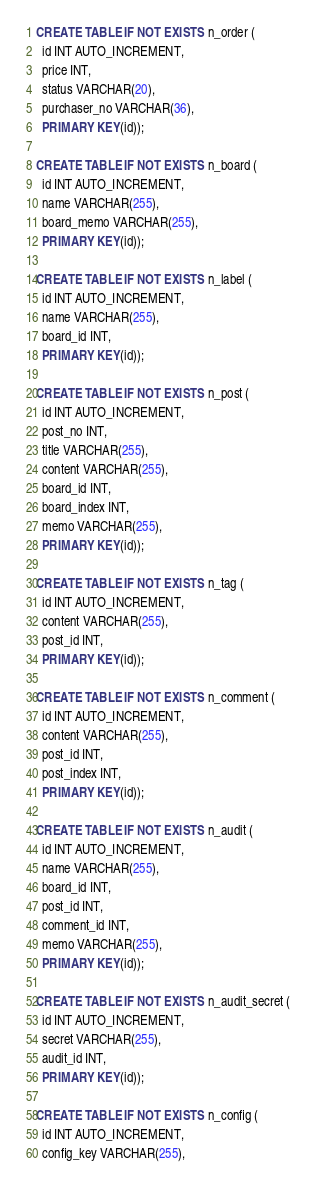<code> <loc_0><loc_0><loc_500><loc_500><_SQL_>CREATE TABLE IF NOT EXISTS n_order (
  id INT AUTO_INCREMENT,
  price INT,
  status VARCHAR(20),
  purchaser_no VARCHAR(36),
  PRIMARY KEY(id));

CREATE TABLE IF NOT EXISTS n_board (
  id INT AUTO_INCREMENT,
  name VARCHAR(255),
  board_memo VARCHAR(255),
  PRIMARY KEY(id));

CREATE TABLE IF NOT EXISTS n_label (
  id INT AUTO_INCREMENT,
  name VARCHAR(255),
  board_id INT,
  PRIMARY KEY(id));

CREATE TABLE IF NOT EXISTS n_post (
  id INT AUTO_INCREMENT,
  post_no INT,
  title VARCHAR(255),
  content VARCHAR(255),
  board_id INT,
  board_index INT,
  memo VARCHAR(255),
  PRIMARY KEY(id));

CREATE TABLE IF NOT EXISTS n_tag (
  id INT AUTO_INCREMENT,
  content VARCHAR(255),
  post_id INT,
  PRIMARY KEY(id));

CREATE TABLE IF NOT EXISTS n_comment (
  id INT AUTO_INCREMENT,
  content VARCHAR(255),
  post_id INT,
  post_index INT,
  PRIMARY KEY(id));

CREATE TABLE IF NOT EXISTS n_audit (
  id INT AUTO_INCREMENT,
  name VARCHAR(255),
  board_id INT,
  post_id INT,
  comment_id INT,
  memo VARCHAR(255),
  PRIMARY KEY(id));

CREATE TABLE IF NOT EXISTS n_audit_secret (
  id INT AUTO_INCREMENT,
  secret VARCHAR(255),
  audit_id INT,
  PRIMARY KEY(id));

CREATE TABLE IF NOT EXISTS n_config (
  id INT AUTO_INCREMENT,
  config_key VARCHAR(255),</code> 